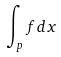<formula> <loc_0><loc_0><loc_500><loc_500>\int _ { p } f d x</formula> 